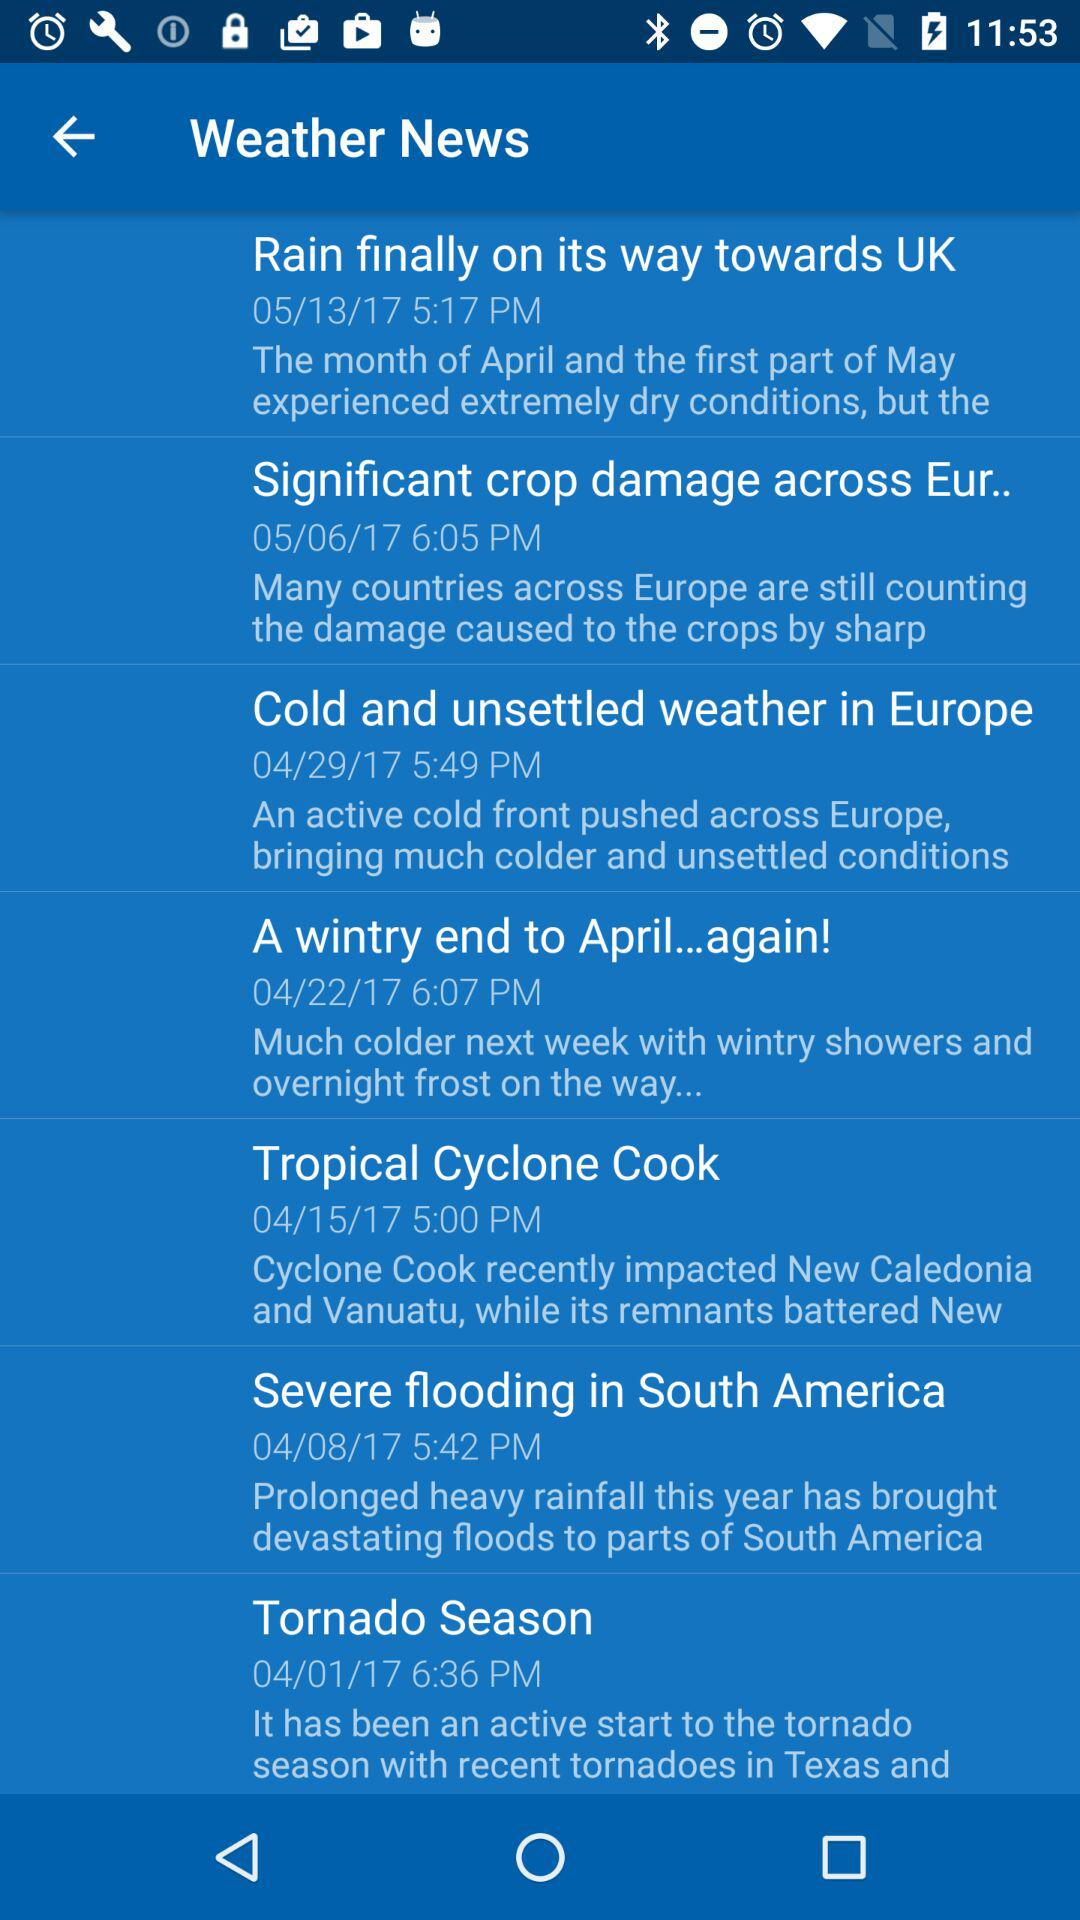How is the weather in Europe? The weather in Europe is cold and unsettled. 